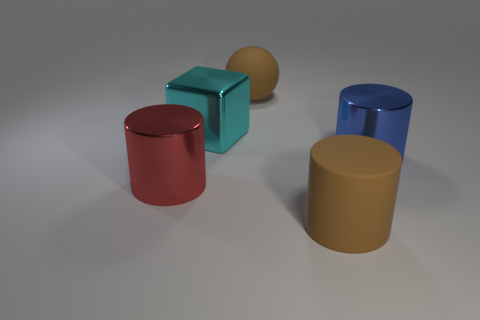Is there a big purple matte object that has the same shape as the big red metal thing?
Provide a succinct answer. No. What shape is the blue shiny thing that is the same size as the red metallic cylinder?
Ensure brevity in your answer.  Cylinder. What is the cyan thing made of?
Ensure brevity in your answer.  Metal. What size is the brown matte thing to the right of the big brown matte ball that is behind the shiny object behind the blue object?
Keep it short and to the point. Large. What is the material of the sphere that is the same color as the matte cylinder?
Give a very brief answer. Rubber. How many shiny things are either large blue cylinders or big things?
Keep it short and to the point. 3. How big is the red metallic cylinder?
Your answer should be very brief. Large. What number of objects are metallic cylinders or big brown rubber objects behind the red metallic thing?
Offer a very short reply. 3. What number of other things are there of the same color as the ball?
Provide a succinct answer. 1. There is a blue object; is it the same size as the brown object behind the big red object?
Provide a succinct answer. Yes. 